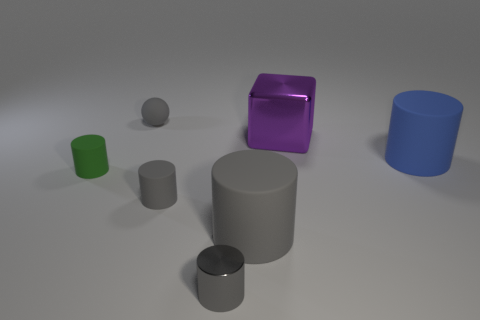Is the number of large shiny cubes that are behind the green rubber cylinder greater than the number of big green matte cylinders?
Give a very brief answer. Yes. There is a large blue matte cylinder; how many tiny objects are in front of it?
Your answer should be very brief. 3. Is there a blue cylinder of the same size as the gray sphere?
Keep it short and to the point. No. There is a tiny metal thing that is the same shape as the blue matte object; what color is it?
Ensure brevity in your answer.  Gray. There is a matte cylinder that is to the right of the large shiny thing; is it the same size as the metallic cube that is behind the green rubber object?
Provide a succinct answer. Yes. Is there a small gray matte object that has the same shape as the tiny green object?
Keep it short and to the point. Yes. Are there an equal number of large metallic blocks right of the green matte thing and cyan spheres?
Keep it short and to the point. No. Do the blue object and the gray rubber cylinder right of the tiny gray metal cylinder have the same size?
Give a very brief answer. Yes. How many gray cylinders are the same material as the blue object?
Ensure brevity in your answer.  2. Is the size of the gray metallic cylinder the same as the blue cylinder?
Ensure brevity in your answer.  No. 